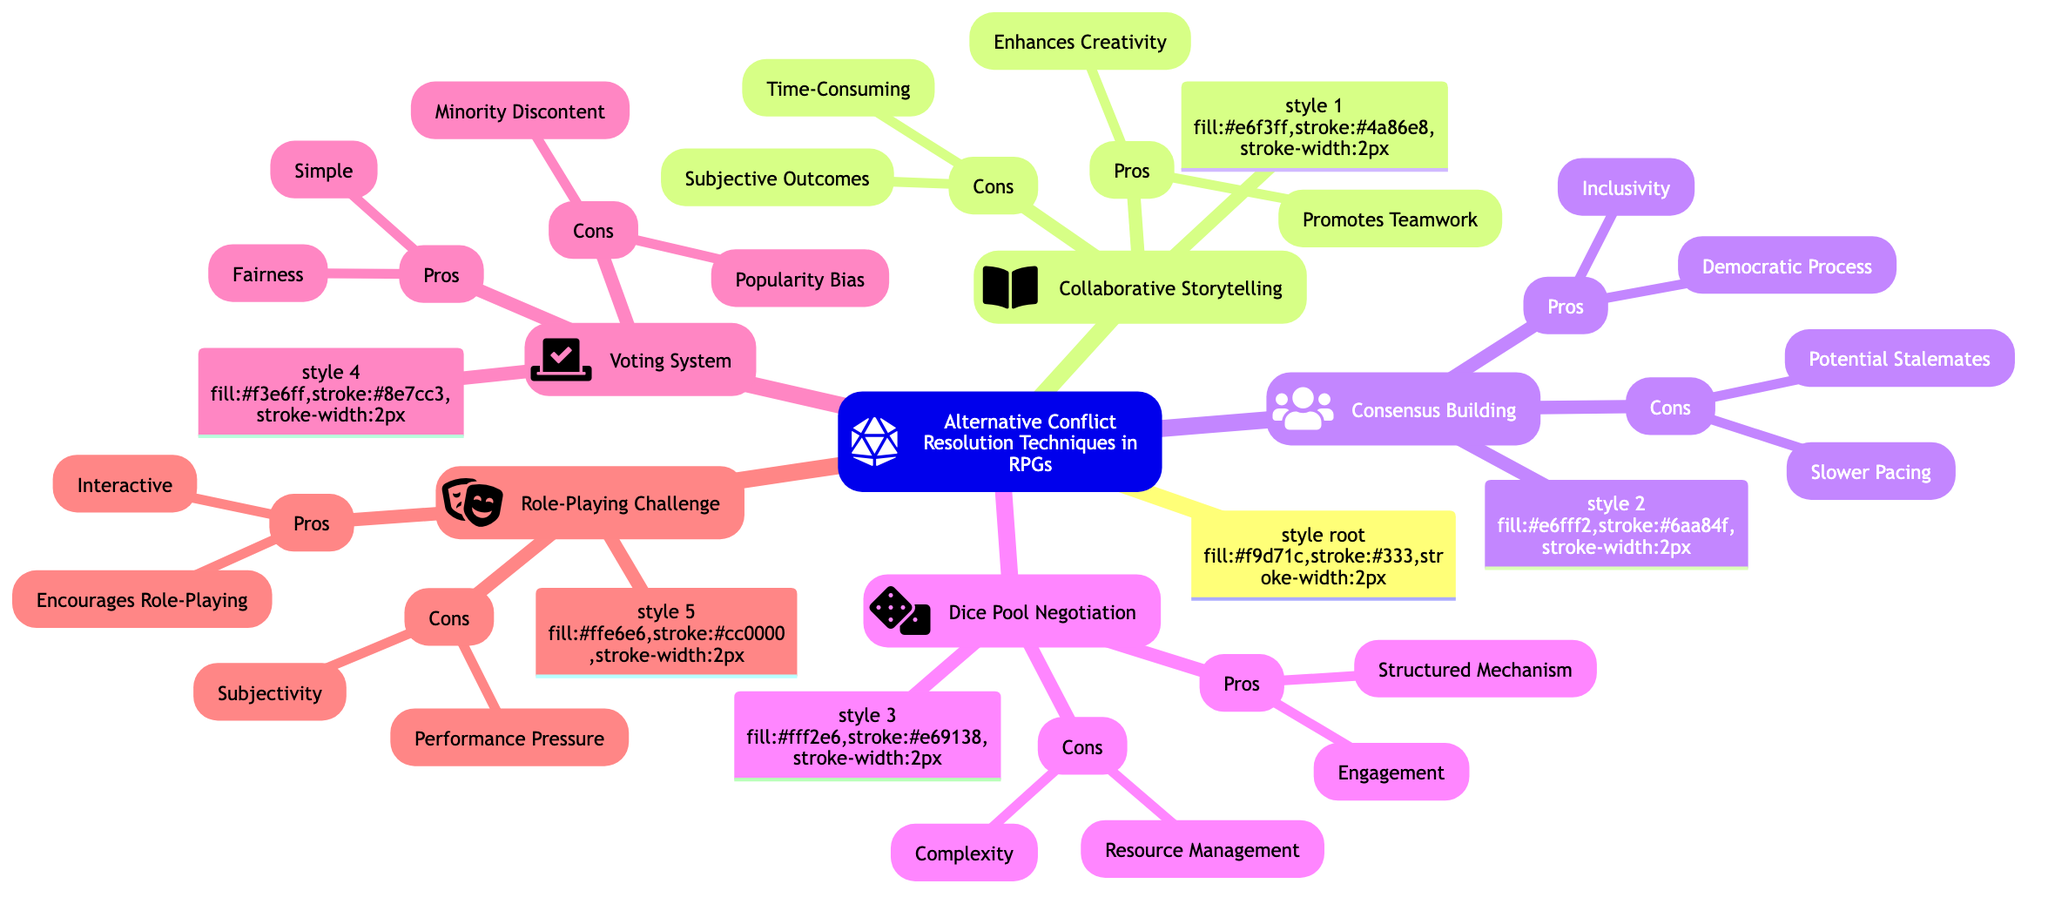What is the main topic of the mind map? The main topic is identified at the root of the diagram, labeled "Alternative Conflict Resolution Techniques in RPGs".
Answer: Alternative Conflict Resolution Techniques in RPGs How many major conflict resolution techniques are listed? By counting the numbered nodes emanating from the root, we find that there are five major techniques listed.
Answer: 5 What is a pro of Collaborative Storytelling? By examining the "Pros" section under "Collaborative Storytelling", one identified pro is "Enhances Creativity".
Answer: Enhances Creativity What is a con of the Voting System? The "Cons" section for the "Voting System" reveals that one con is "Minority Discontent".
Answer: Minority Discontent Which technique emphasizes a structured mechanism for conflict resolution? Looking at the "Pros" of "Dice Pool Negotiation", it clearly states "Structured Mechanism" as a benefit.
Answer: Dice Pool Negotiation What does Consensus Building promote among participants? The "Pros" of "Consensus Building" include "Inclusivity", which emphasizes equal participation.
Answer: Inclusivity In which technique is performance judged by the GM or peers? The description of "Role-Playing Challenge" states that conflicts are resolved through role-playing judged by the GM or peers.
Answer: Role-Playing Challenge How are conflicts resolved in the Voting System? The description in the "Voting System" notes that conflicts are resolved by majority vote among players.
Answer: Majority vote What is a disadvantage of Collaborative Storytelling? One con listed in the "Cons" section for "Collaborative Storytelling" is "Time-Consuming".
Answer: Time-Consuming 